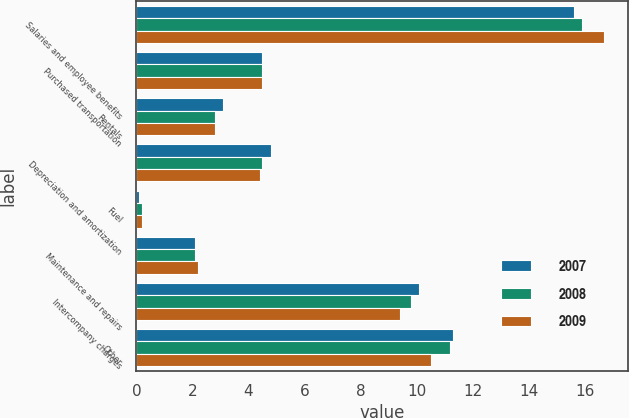<chart> <loc_0><loc_0><loc_500><loc_500><stacked_bar_chart><ecel><fcel>Salaries and employee benefits<fcel>Purchased transportation<fcel>Rentals<fcel>Depreciation and amortization<fcel>Fuel<fcel>Maintenance and repairs<fcel>Intercompany charges<fcel>Other<nl><fcel>2007<fcel>15.6<fcel>4.5<fcel>3.1<fcel>4.8<fcel>0.1<fcel>2.1<fcel>10.1<fcel>11.3<nl><fcel>2008<fcel>15.9<fcel>4.5<fcel>2.8<fcel>4.5<fcel>0.2<fcel>2.1<fcel>9.8<fcel>11.2<nl><fcel>2009<fcel>16.7<fcel>4.5<fcel>2.8<fcel>4.4<fcel>0.2<fcel>2.2<fcel>9.4<fcel>10.5<nl></chart> 